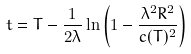<formula> <loc_0><loc_0><loc_500><loc_500>t = T - \frac { 1 } { 2 \lambda } \ln \left ( 1 - \frac { \lambda ^ { 2 } R ^ { 2 } } { c ( T ) ^ { 2 } } \right )</formula> 